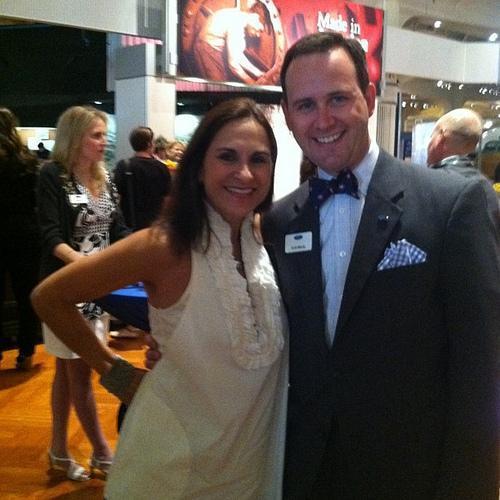How many people are looking at the photographer?
Give a very brief answer. 2. How many people are visible?
Give a very brief answer. 8. How many people are posing for the camera?
Give a very brief answer. 2. 